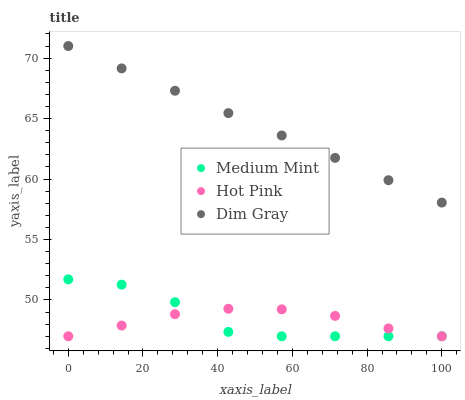Does Hot Pink have the minimum area under the curve?
Answer yes or no. Yes. Does Dim Gray have the maximum area under the curve?
Answer yes or no. Yes. Does Dim Gray have the minimum area under the curve?
Answer yes or no. No. Does Hot Pink have the maximum area under the curve?
Answer yes or no. No. Is Dim Gray the smoothest?
Answer yes or no. Yes. Is Medium Mint the roughest?
Answer yes or no. Yes. Is Hot Pink the smoothest?
Answer yes or no. No. Is Hot Pink the roughest?
Answer yes or no. No. Does Medium Mint have the lowest value?
Answer yes or no. Yes. Does Dim Gray have the lowest value?
Answer yes or no. No. Does Dim Gray have the highest value?
Answer yes or no. Yes. Does Hot Pink have the highest value?
Answer yes or no. No. Is Medium Mint less than Dim Gray?
Answer yes or no. Yes. Is Dim Gray greater than Hot Pink?
Answer yes or no. Yes. Does Medium Mint intersect Hot Pink?
Answer yes or no. Yes. Is Medium Mint less than Hot Pink?
Answer yes or no. No. Is Medium Mint greater than Hot Pink?
Answer yes or no. No. Does Medium Mint intersect Dim Gray?
Answer yes or no. No. 